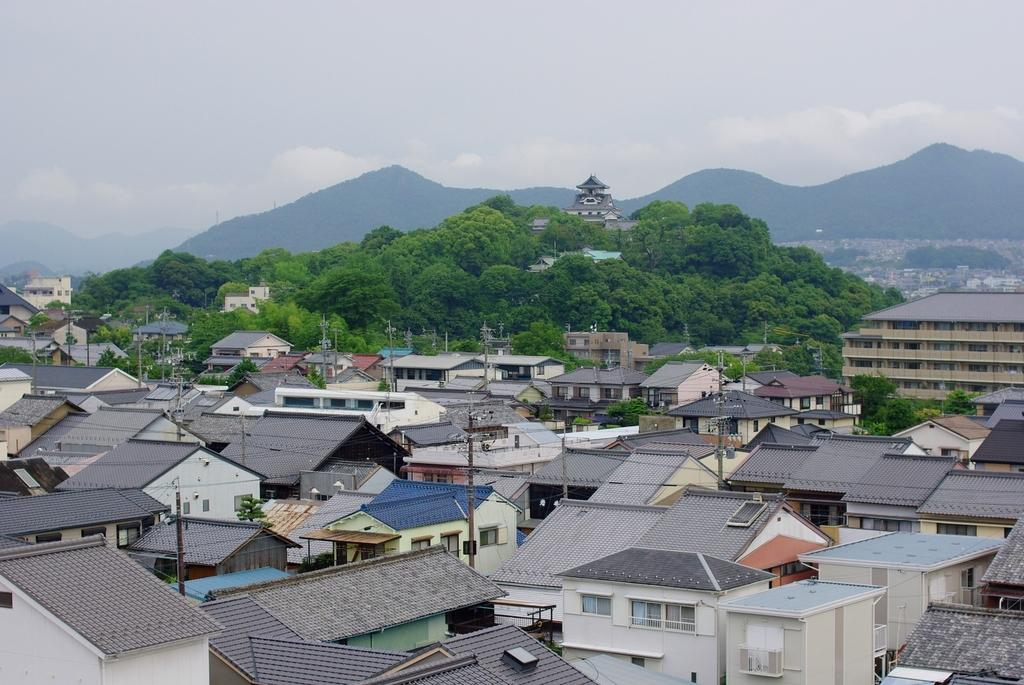What type of structures can be seen in the image? There are buildings, houses, and poles with wires in the image. What type of vegetation is present in the image? There are trees in the image. What type of terrain is visible in the image? There are hills visible in the image. What is visible at the top of the image? The sky is visible at the top of the image. What type of jeans can be seen hanging on the trees in the image? There are no jeans present in the image; it features buildings, houses, trees, poles with wires, hills, and the sky. What shape is the yam that is growing on the hills in the image? There is no yam present in the image; it features buildings, houses, trees, poles with wires, hills, and the sky. 